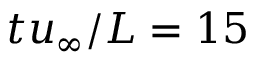Convert formula to latex. <formula><loc_0><loc_0><loc_500><loc_500>t u _ { \infty } / L = 1 5</formula> 